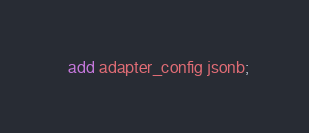Convert code to text. <code><loc_0><loc_0><loc_500><loc_500><_SQL_>  add adapter_config jsonb;
</code> 